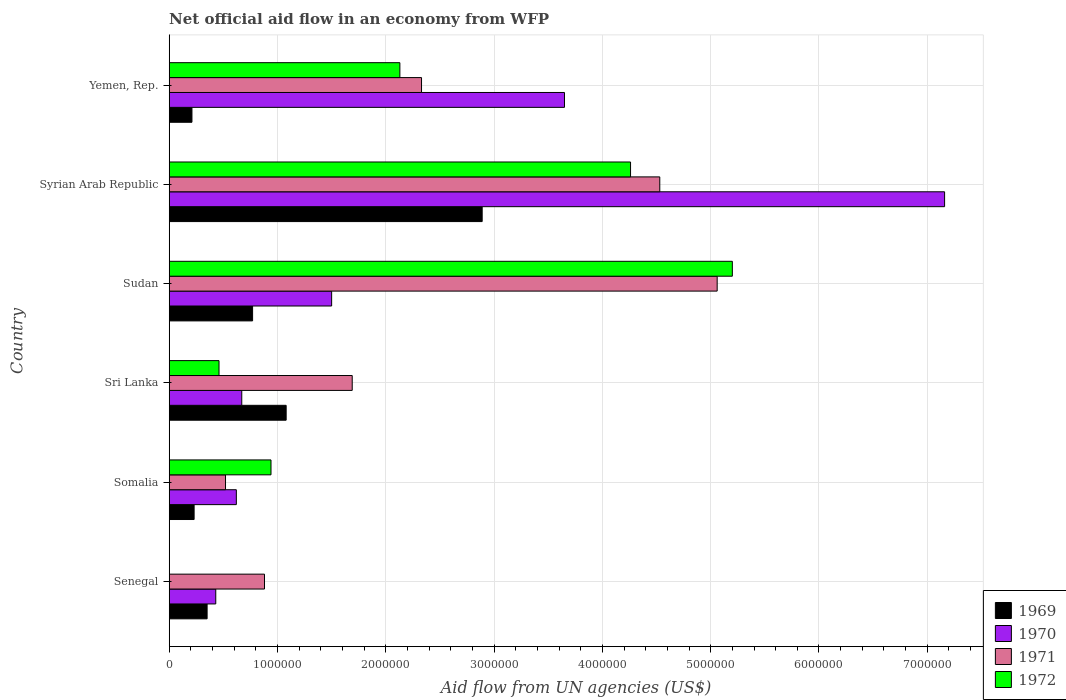How many groups of bars are there?
Offer a very short reply. 6. Are the number of bars on each tick of the Y-axis equal?
Provide a short and direct response. No. How many bars are there on the 4th tick from the top?
Make the answer very short. 4. What is the label of the 6th group of bars from the top?
Give a very brief answer. Senegal. What is the net official aid flow in 1970 in Sri Lanka?
Your answer should be very brief. 6.70e+05. Across all countries, what is the maximum net official aid flow in 1971?
Ensure brevity in your answer.  5.06e+06. In which country was the net official aid flow in 1971 maximum?
Give a very brief answer. Sudan. What is the total net official aid flow in 1971 in the graph?
Ensure brevity in your answer.  1.50e+07. What is the difference between the net official aid flow in 1972 in Somalia and the net official aid flow in 1969 in Senegal?
Give a very brief answer. 5.90e+05. What is the average net official aid flow in 1970 per country?
Your response must be concise. 2.34e+06. What is the difference between the net official aid flow in 1972 and net official aid flow in 1971 in Sudan?
Give a very brief answer. 1.40e+05. In how many countries, is the net official aid flow in 1969 greater than 4200000 US$?
Your answer should be very brief. 0. What is the ratio of the net official aid flow in 1970 in Somalia to that in Sudan?
Your answer should be compact. 0.41. What is the difference between the highest and the second highest net official aid flow in 1971?
Offer a terse response. 5.30e+05. What is the difference between the highest and the lowest net official aid flow in 1972?
Offer a terse response. 5.20e+06. Is it the case that in every country, the sum of the net official aid flow in 1969 and net official aid flow in 1970 is greater than the net official aid flow in 1971?
Make the answer very short. No. What is the difference between two consecutive major ticks on the X-axis?
Provide a succinct answer. 1.00e+06. Does the graph contain grids?
Offer a terse response. Yes. Where does the legend appear in the graph?
Give a very brief answer. Bottom right. How many legend labels are there?
Offer a very short reply. 4. What is the title of the graph?
Provide a succinct answer. Net official aid flow in an economy from WFP. What is the label or title of the X-axis?
Your answer should be compact. Aid flow from UN agencies (US$). What is the label or title of the Y-axis?
Your response must be concise. Country. What is the Aid flow from UN agencies (US$) of 1969 in Senegal?
Your response must be concise. 3.50e+05. What is the Aid flow from UN agencies (US$) of 1970 in Senegal?
Offer a terse response. 4.30e+05. What is the Aid flow from UN agencies (US$) in 1971 in Senegal?
Provide a succinct answer. 8.80e+05. What is the Aid flow from UN agencies (US$) in 1970 in Somalia?
Your response must be concise. 6.20e+05. What is the Aid flow from UN agencies (US$) in 1971 in Somalia?
Your response must be concise. 5.20e+05. What is the Aid flow from UN agencies (US$) of 1972 in Somalia?
Provide a short and direct response. 9.40e+05. What is the Aid flow from UN agencies (US$) of 1969 in Sri Lanka?
Keep it short and to the point. 1.08e+06. What is the Aid flow from UN agencies (US$) of 1970 in Sri Lanka?
Provide a short and direct response. 6.70e+05. What is the Aid flow from UN agencies (US$) in 1971 in Sri Lanka?
Make the answer very short. 1.69e+06. What is the Aid flow from UN agencies (US$) of 1969 in Sudan?
Offer a terse response. 7.70e+05. What is the Aid flow from UN agencies (US$) of 1970 in Sudan?
Keep it short and to the point. 1.50e+06. What is the Aid flow from UN agencies (US$) in 1971 in Sudan?
Ensure brevity in your answer.  5.06e+06. What is the Aid flow from UN agencies (US$) in 1972 in Sudan?
Give a very brief answer. 5.20e+06. What is the Aid flow from UN agencies (US$) of 1969 in Syrian Arab Republic?
Provide a succinct answer. 2.89e+06. What is the Aid flow from UN agencies (US$) of 1970 in Syrian Arab Republic?
Give a very brief answer. 7.16e+06. What is the Aid flow from UN agencies (US$) in 1971 in Syrian Arab Republic?
Your response must be concise. 4.53e+06. What is the Aid flow from UN agencies (US$) in 1972 in Syrian Arab Republic?
Your answer should be compact. 4.26e+06. What is the Aid flow from UN agencies (US$) of 1969 in Yemen, Rep.?
Offer a very short reply. 2.10e+05. What is the Aid flow from UN agencies (US$) in 1970 in Yemen, Rep.?
Give a very brief answer. 3.65e+06. What is the Aid flow from UN agencies (US$) in 1971 in Yemen, Rep.?
Offer a terse response. 2.33e+06. What is the Aid flow from UN agencies (US$) of 1972 in Yemen, Rep.?
Offer a very short reply. 2.13e+06. Across all countries, what is the maximum Aid flow from UN agencies (US$) in 1969?
Provide a succinct answer. 2.89e+06. Across all countries, what is the maximum Aid flow from UN agencies (US$) in 1970?
Your answer should be very brief. 7.16e+06. Across all countries, what is the maximum Aid flow from UN agencies (US$) in 1971?
Make the answer very short. 5.06e+06. Across all countries, what is the maximum Aid flow from UN agencies (US$) of 1972?
Your answer should be compact. 5.20e+06. Across all countries, what is the minimum Aid flow from UN agencies (US$) in 1969?
Offer a terse response. 2.10e+05. Across all countries, what is the minimum Aid flow from UN agencies (US$) in 1970?
Provide a succinct answer. 4.30e+05. Across all countries, what is the minimum Aid flow from UN agencies (US$) of 1971?
Your answer should be very brief. 5.20e+05. Across all countries, what is the minimum Aid flow from UN agencies (US$) of 1972?
Offer a terse response. 0. What is the total Aid flow from UN agencies (US$) in 1969 in the graph?
Your answer should be compact. 5.53e+06. What is the total Aid flow from UN agencies (US$) of 1970 in the graph?
Your response must be concise. 1.40e+07. What is the total Aid flow from UN agencies (US$) of 1971 in the graph?
Your answer should be compact. 1.50e+07. What is the total Aid flow from UN agencies (US$) of 1972 in the graph?
Provide a succinct answer. 1.30e+07. What is the difference between the Aid flow from UN agencies (US$) of 1969 in Senegal and that in Somalia?
Keep it short and to the point. 1.20e+05. What is the difference between the Aid flow from UN agencies (US$) of 1969 in Senegal and that in Sri Lanka?
Offer a terse response. -7.30e+05. What is the difference between the Aid flow from UN agencies (US$) of 1970 in Senegal and that in Sri Lanka?
Ensure brevity in your answer.  -2.40e+05. What is the difference between the Aid flow from UN agencies (US$) of 1971 in Senegal and that in Sri Lanka?
Keep it short and to the point. -8.10e+05. What is the difference between the Aid flow from UN agencies (US$) of 1969 in Senegal and that in Sudan?
Provide a short and direct response. -4.20e+05. What is the difference between the Aid flow from UN agencies (US$) of 1970 in Senegal and that in Sudan?
Your response must be concise. -1.07e+06. What is the difference between the Aid flow from UN agencies (US$) of 1971 in Senegal and that in Sudan?
Offer a very short reply. -4.18e+06. What is the difference between the Aid flow from UN agencies (US$) of 1969 in Senegal and that in Syrian Arab Republic?
Offer a terse response. -2.54e+06. What is the difference between the Aid flow from UN agencies (US$) in 1970 in Senegal and that in Syrian Arab Republic?
Give a very brief answer. -6.73e+06. What is the difference between the Aid flow from UN agencies (US$) of 1971 in Senegal and that in Syrian Arab Republic?
Your response must be concise. -3.65e+06. What is the difference between the Aid flow from UN agencies (US$) of 1970 in Senegal and that in Yemen, Rep.?
Your answer should be very brief. -3.22e+06. What is the difference between the Aid flow from UN agencies (US$) of 1971 in Senegal and that in Yemen, Rep.?
Provide a short and direct response. -1.45e+06. What is the difference between the Aid flow from UN agencies (US$) in 1969 in Somalia and that in Sri Lanka?
Keep it short and to the point. -8.50e+05. What is the difference between the Aid flow from UN agencies (US$) of 1971 in Somalia and that in Sri Lanka?
Provide a succinct answer. -1.17e+06. What is the difference between the Aid flow from UN agencies (US$) of 1969 in Somalia and that in Sudan?
Offer a very short reply. -5.40e+05. What is the difference between the Aid flow from UN agencies (US$) in 1970 in Somalia and that in Sudan?
Make the answer very short. -8.80e+05. What is the difference between the Aid flow from UN agencies (US$) in 1971 in Somalia and that in Sudan?
Offer a very short reply. -4.54e+06. What is the difference between the Aid flow from UN agencies (US$) of 1972 in Somalia and that in Sudan?
Provide a succinct answer. -4.26e+06. What is the difference between the Aid flow from UN agencies (US$) in 1969 in Somalia and that in Syrian Arab Republic?
Your response must be concise. -2.66e+06. What is the difference between the Aid flow from UN agencies (US$) in 1970 in Somalia and that in Syrian Arab Republic?
Your answer should be very brief. -6.54e+06. What is the difference between the Aid flow from UN agencies (US$) in 1971 in Somalia and that in Syrian Arab Republic?
Keep it short and to the point. -4.01e+06. What is the difference between the Aid flow from UN agencies (US$) of 1972 in Somalia and that in Syrian Arab Republic?
Ensure brevity in your answer.  -3.32e+06. What is the difference between the Aid flow from UN agencies (US$) in 1969 in Somalia and that in Yemen, Rep.?
Keep it short and to the point. 2.00e+04. What is the difference between the Aid flow from UN agencies (US$) in 1970 in Somalia and that in Yemen, Rep.?
Keep it short and to the point. -3.03e+06. What is the difference between the Aid flow from UN agencies (US$) in 1971 in Somalia and that in Yemen, Rep.?
Offer a terse response. -1.81e+06. What is the difference between the Aid flow from UN agencies (US$) of 1972 in Somalia and that in Yemen, Rep.?
Provide a succinct answer. -1.19e+06. What is the difference between the Aid flow from UN agencies (US$) of 1969 in Sri Lanka and that in Sudan?
Give a very brief answer. 3.10e+05. What is the difference between the Aid flow from UN agencies (US$) of 1970 in Sri Lanka and that in Sudan?
Give a very brief answer. -8.30e+05. What is the difference between the Aid flow from UN agencies (US$) in 1971 in Sri Lanka and that in Sudan?
Provide a short and direct response. -3.37e+06. What is the difference between the Aid flow from UN agencies (US$) in 1972 in Sri Lanka and that in Sudan?
Make the answer very short. -4.74e+06. What is the difference between the Aid flow from UN agencies (US$) in 1969 in Sri Lanka and that in Syrian Arab Republic?
Make the answer very short. -1.81e+06. What is the difference between the Aid flow from UN agencies (US$) of 1970 in Sri Lanka and that in Syrian Arab Republic?
Keep it short and to the point. -6.49e+06. What is the difference between the Aid flow from UN agencies (US$) in 1971 in Sri Lanka and that in Syrian Arab Republic?
Ensure brevity in your answer.  -2.84e+06. What is the difference between the Aid flow from UN agencies (US$) in 1972 in Sri Lanka and that in Syrian Arab Republic?
Keep it short and to the point. -3.80e+06. What is the difference between the Aid flow from UN agencies (US$) of 1969 in Sri Lanka and that in Yemen, Rep.?
Provide a succinct answer. 8.70e+05. What is the difference between the Aid flow from UN agencies (US$) in 1970 in Sri Lanka and that in Yemen, Rep.?
Your answer should be compact. -2.98e+06. What is the difference between the Aid flow from UN agencies (US$) of 1971 in Sri Lanka and that in Yemen, Rep.?
Ensure brevity in your answer.  -6.40e+05. What is the difference between the Aid flow from UN agencies (US$) of 1972 in Sri Lanka and that in Yemen, Rep.?
Ensure brevity in your answer.  -1.67e+06. What is the difference between the Aid flow from UN agencies (US$) of 1969 in Sudan and that in Syrian Arab Republic?
Keep it short and to the point. -2.12e+06. What is the difference between the Aid flow from UN agencies (US$) of 1970 in Sudan and that in Syrian Arab Republic?
Your answer should be compact. -5.66e+06. What is the difference between the Aid flow from UN agencies (US$) in 1971 in Sudan and that in Syrian Arab Republic?
Ensure brevity in your answer.  5.30e+05. What is the difference between the Aid flow from UN agencies (US$) in 1972 in Sudan and that in Syrian Arab Republic?
Your answer should be compact. 9.40e+05. What is the difference between the Aid flow from UN agencies (US$) in 1969 in Sudan and that in Yemen, Rep.?
Ensure brevity in your answer.  5.60e+05. What is the difference between the Aid flow from UN agencies (US$) of 1970 in Sudan and that in Yemen, Rep.?
Give a very brief answer. -2.15e+06. What is the difference between the Aid flow from UN agencies (US$) of 1971 in Sudan and that in Yemen, Rep.?
Your response must be concise. 2.73e+06. What is the difference between the Aid flow from UN agencies (US$) of 1972 in Sudan and that in Yemen, Rep.?
Make the answer very short. 3.07e+06. What is the difference between the Aid flow from UN agencies (US$) in 1969 in Syrian Arab Republic and that in Yemen, Rep.?
Keep it short and to the point. 2.68e+06. What is the difference between the Aid flow from UN agencies (US$) of 1970 in Syrian Arab Republic and that in Yemen, Rep.?
Ensure brevity in your answer.  3.51e+06. What is the difference between the Aid flow from UN agencies (US$) in 1971 in Syrian Arab Republic and that in Yemen, Rep.?
Keep it short and to the point. 2.20e+06. What is the difference between the Aid flow from UN agencies (US$) of 1972 in Syrian Arab Republic and that in Yemen, Rep.?
Offer a terse response. 2.13e+06. What is the difference between the Aid flow from UN agencies (US$) of 1969 in Senegal and the Aid flow from UN agencies (US$) of 1970 in Somalia?
Offer a very short reply. -2.70e+05. What is the difference between the Aid flow from UN agencies (US$) of 1969 in Senegal and the Aid flow from UN agencies (US$) of 1971 in Somalia?
Provide a short and direct response. -1.70e+05. What is the difference between the Aid flow from UN agencies (US$) of 1969 in Senegal and the Aid flow from UN agencies (US$) of 1972 in Somalia?
Make the answer very short. -5.90e+05. What is the difference between the Aid flow from UN agencies (US$) in 1970 in Senegal and the Aid flow from UN agencies (US$) in 1971 in Somalia?
Offer a very short reply. -9.00e+04. What is the difference between the Aid flow from UN agencies (US$) in 1970 in Senegal and the Aid flow from UN agencies (US$) in 1972 in Somalia?
Ensure brevity in your answer.  -5.10e+05. What is the difference between the Aid flow from UN agencies (US$) in 1971 in Senegal and the Aid flow from UN agencies (US$) in 1972 in Somalia?
Your response must be concise. -6.00e+04. What is the difference between the Aid flow from UN agencies (US$) in 1969 in Senegal and the Aid flow from UN agencies (US$) in 1970 in Sri Lanka?
Ensure brevity in your answer.  -3.20e+05. What is the difference between the Aid flow from UN agencies (US$) of 1969 in Senegal and the Aid flow from UN agencies (US$) of 1971 in Sri Lanka?
Offer a very short reply. -1.34e+06. What is the difference between the Aid flow from UN agencies (US$) in 1969 in Senegal and the Aid flow from UN agencies (US$) in 1972 in Sri Lanka?
Ensure brevity in your answer.  -1.10e+05. What is the difference between the Aid flow from UN agencies (US$) of 1970 in Senegal and the Aid flow from UN agencies (US$) of 1971 in Sri Lanka?
Your response must be concise. -1.26e+06. What is the difference between the Aid flow from UN agencies (US$) in 1970 in Senegal and the Aid flow from UN agencies (US$) in 1972 in Sri Lanka?
Provide a short and direct response. -3.00e+04. What is the difference between the Aid flow from UN agencies (US$) in 1971 in Senegal and the Aid flow from UN agencies (US$) in 1972 in Sri Lanka?
Ensure brevity in your answer.  4.20e+05. What is the difference between the Aid flow from UN agencies (US$) of 1969 in Senegal and the Aid flow from UN agencies (US$) of 1970 in Sudan?
Your answer should be very brief. -1.15e+06. What is the difference between the Aid flow from UN agencies (US$) in 1969 in Senegal and the Aid flow from UN agencies (US$) in 1971 in Sudan?
Provide a succinct answer. -4.71e+06. What is the difference between the Aid flow from UN agencies (US$) of 1969 in Senegal and the Aid flow from UN agencies (US$) of 1972 in Sudan?
Give a very brief answer. -4.85e+06. What is the difference between the Aid flow from UN agencies (US$) of 1970 in Senegal and the Aid flow from UN agencies (US$) of 1971 in Sudan?
Ensure brevity in your answer.  -4.63e+06. What is the difference between the Aid flow from UN agencies (US$) in 1970 in Senegal and the Aid flow from UN agencies (US$) in 1972 in Sudan?
Offer a very short reply. -4.77e+06. What is the difference between the Aid flow from UN agencies (US$) of 1971 in Senegal and the Aid flow from UN agencies (US$) of 1972 in Sudan?
Keep it short and to the point. -4.32e+06. What is the difference between the Aid flow from UN agencies (US$) of 1969 in Senegal and the Aid flow from UN agencies (US$) of 1970 in Syrian Arab Republic?
Provide a succinct answer. -6.81e+06. What is the difference between the Aid flow from UN agencies (US$) of 1969 in Senegal and the Aid flow from UN agencies (US$) of 1971 in Syrian Arab Republic?
Make the answer very short. -4.18e+06. What is the difference between the Aid flow from UN agencies (US$) of 1969 in Senegal and the Aid flow from UN agencies (US$) of 1972 in Syrian Arab Republic?
Give a very brief answer. -3.91e+06. What is the difference between the Aid flow from UN agencies (US$) of 1970 in Senegal and the Aid flow from UN agencies (US$) of 1971 in Syrian Arab Republic?
Offer a terse response. -4.10e+06. What is the difference between the Aid flow from UN agencies (US$) in 1970 in Senegal and the Aid flow from UN agencies (US$) in 1972 in Syrian Arab Republic?
Provide a succinct answer. -3.83e+06. What is the difference between the Aid flow from UN agencies (US$) in 1971 in Senegal and the Aid flow from UN agencies (US$) in 1972 in Syrian Arab Republic?
Offer a terse response. -3.38e+06. What is the difference between the Aid flow from UN agencies (US$) in 1969 in Senegal and the Aid flow from UN agencies (US$) in 1970 in Yemen, Rep.?
Provide a succinct answer. -3.30e+06. What is the difference between the Aid flow from UN agencies (US$) in 1969 in Senegal and the Aid flow from UN agencies (US$) in 1971 in Yemen, Rep.?
Ensure brevity in your answer.  -1.98e+06. What is the difference between the Aid flow from UN agencies (US$) of 1969 in Senegal and the Aid flow from UN agencies (US$) of 1972 in Yemen, Rep.?
Offer a terse response. -1.78e+06. What is the difference between the Aid flow from UN agencies (US$) in 1970 in Senegal and the Aid flow from UN agencies (US$) in 1971 in Yemen, Rep.?
Ensure brevity in your answer.  -1.90e+06. What is the difference between the Aid flow from UN agencies (US$) in 1970 in Senegal and the Aid flow from UN agencies (US$) in 1972 in Yemen, Rep.?
Offer a terse response. -1.70e+06. What is the difference between the Aid flow from UN agencies (US$) of 1971 in Senegal and the Aid flow from UN agencies (US$) of 1972 in Yemen, Rep.?
Your answer should be compact. -1.25e+06. What is the difference between the Aid flow from UN agencies (US$) of 1969 in Somalia and the Aid flow from UN agencies (US$) of 1970 in Sri Lanka?
Offer a very short reply. -4.40e+05. What is the difference between the Aid flow from UN agencies (US$) in 1969 in Somalia and the Aid flow from UN agencies (US$) in 1971 in Sri Lanka?
Offer a very short reply. -1.46e+06. What is the difference between the Aid flow from UN agencies (US$) of 1969 in Somalia and the Aid flow from UN agencies (US$) of 1972 in Sri Lanka?
Make the answer very short. -2.30e+05. What is the difference between the Aid flow from UN agencies (US$) of 1970 in Somalia and the Aid flow from UN agencies (US$) of 1971 in Sri Lanka?
Give a very brief answer. -1.07e+06. What is the difference between the Aid flow from UN agencies (US$) of 1970 in Somalia and the Aid flow from UN agencies (US$) of 1972 in Sri Lanka?
Give a very brief answer. 1.60e+05. What is the difference between the Aid flow from UN agencies (US$) of 1971 in Somalia and the Aid flow from UN agencies (US$) of 1972 in Sri Lanka?
Your response must be concise. 6.00e+04. What is the difference between the Aid flow from UN agencies (US$) in 1969 in Somalia and the Aid flow from UN agencies (US$) in 1970 in Sudan?
Your answer should be very brief. -1.27e+06. What is the difference between the Aid flow from UN agencies (US$) in 1969 in Somalia and the Aid flow from UN agencies (US$) in 1971 in Sudan?
Provide a succinct answer. -4.83e+06. What is the difference between the Aid flow from UN agencies (US$) in 1969 in Somalia and the Aid flow from UN agencies (US$) in 1972 in Sudan?
Ensure brevity in your answer.  -4.97e+06. What is the difference between the Aid flow from UN agencies (US$) in 1970 in Somalia and the Aid flow from UN agencies (US$) in 1971 in Sudan?
Keep it short and to the point. -4.44e+06. What is the difference between the Aid flow from UN agencies (US$) of 1970 in Somalia and the Aid flow from UN agencies (US$) of 1972 in Sudan?
Give a very brief answer. -4.58e+06. What is the difference between the Aid flow from UN agencies (US$) in 1971 in Somalia and the Aid flow from UN agencies (US$) in 1972 in Sudan?
Your answer should be compact. -4.68e+06. What is the difference between the Aid flow from UN agencies (US$) in 1969 in Somalia and the Aid flow from UN agencies (US$) in 1970 in Syrian Arab Republic?
Ensure brevity in your answer.  -6.93e+06. What is the difference between the Aid flow from UN agencies (US$) of 1969 in Somalia and the Aid flow from UN agencies (US$) of 1971 in Syrian Arab Republic?
Ensure brevity in your answer.  -4.30e+06. What is the difference between the Aid flow from UN agencies (US$) of 1969 in Somalia and the Aid flow from UN agencies (US$) of 1972 in Syrian Arab Republic?
Ensure brevity in your answer.  -4.03e+06. What is the difference between the Aid flow from UN agencies (US$) in 1970 in Somalia and the Aid flow from UN agencies (US$) in 1971 in Syrian Arab Republic?
Give a very brief answer. -3.91e+06. What is the difference between the Aid flow from UN agencies (US$) in 1970 in Somalia and the Aid flow from UN agencies (US$) in 1972 in Syrian Arab Republic?
Provide a succinct answer. -3.64e+06. What is the difference between the Aid flow from UN agencies (US$) of 1971 in Somalia and the Aid flow from UN agencies (US$) of 1972 in Syrian Arab Republic?
Keep it short and to the point. -3.74e+06. What is the difference between the Aid flow from UN agencies (US$) of 1969 in Somalia and the Aid flow from UN agencies (US$) of 1970 in Yemen, Rep.?
Provide a succinct answer. -3.42e+06. What is the difference between the Aid flow from UN agencies (US$) of 1969 in Somalia and the Aid flow from UN agencies (US$) of 1971 in Yemen, Rep.?
Your answer should be compact. -2.10e+06. What is the difference between the Aid flow from UN agencies (US$) in 1969 in Somalia and the Aid flow from UN agencies (US$) in 1972 in Yemen, Rep.?
Your response must be concise. -1.90e+06. What is the difference between the Aid flow from UN agencies (US$) in 1970 in Somalia and the Aid flow from UN agencies (US$) in 1971 in Yemen, Rep.?
Your answer should be compact. -1.71e+06. What is the difference between the Aid flow from UN agencies (US$) of 1970 in Somalia and the Aid flow from UN agencies (US$) of 1972 in Yemen, Rep.?
Offer a terse response. -1.51e+06. What is the difference between the Aid flow from UN agencies (US$) in 1971 in Somalia and the Aid flow from UN agencies (US$) in 1972 in Yemen, Rep.?
Provide a short and direct response. -1.61e+06. What is the difference between the Aid flow from UN agencies (US$) in 1969 in Sri Lanka and the Aid flow from UN agencies (US$) in 1970 in Sudan?
Your response must be concise. -4.20e+05. What is the difference between the Aid flow from UN agencies (US$) of 1969 in Sri Lanka and the Aid flow from UN agencies (US$) of 1971 in Sudan?
Provide a short and direct response. -3.98e+06. What is the difference between the Aid flow from UN agencies (US$) in 1969 in Sri Lanka and the Aid flow from UN agencies (US$) in 1972 in Sudan?
Provide a short and direct response. -4.12e+06. What is the difference between the Aid flow from UN agencies (US$) of 1970 in Sri Lanka and the Aid flow from UN agencies (US$) of 1971 in Sudan?
Your answer should be very brief. -4.39e+06. What is the difference between the Aid flow from UN agencies (US$) in 1970 in Sri Lanka and the Aid flow from UN agencies (US$) in 1972 in Sudan?
Give a very brief answer. -4.53e+06. What is the difference between the Aid flow from UN agencies (US$) of 1971 in Sri Lanka and the Aid flow from UN agencies (US$) of 1972 in Sudan?
Your answer should be very brief. -3.51e+06. What is the difference between the Aid flow from UN agencies (US$) in 1969 in Sri Lanka and the Aid flow from UN agencies (US$) in 1970 in Syrian Arab Republic?
Ensure brevity in your answer.  -6.08e+06. What is the difference between the Aid flow from UN agencies (US$) in 1969 in Sri Lanka and the Aid flow from UN agencies (US$) in 1971 in Syrian Arab Republic?
Your answer should be compact. -3.45e+06. What is the difference between the Aid flow from UN agencies (US$) in 1969 in Sri Lanka and the Aid flow from UN agencies (US$) in 1972 in Syrian Arab Republic?
Keep it short and to the point. -3.18e+06. What is the difference between the Aid flow from UN agencies (US$) of 1970 in Sri Lanka and the Aid flow from UN agencies (US$) of 1971 in Syrian Arab Republic?
Offer a terse response. -3.86e+06. What is the difference between the Aid flow from UN agencies (US$) in 1970 in Sri Lanka and the Aid flow from UN agencies (US$) in 1972 in Syrian Arab Republic?
Give a very brief answer. -3.59e+06. What is the difference between the Aid flow from UN agencies (US$) in 1971 in Sri Lanka and the Aid flow from UN agencies (US$) in 1972 in Syrian Arab Republic?
Make the answer very short. -2.57e+06. What is the difference between the Aid flow from UN agencies (US$) in 1969 in Sri Lanka and the Aid flow from UN agencies (US$) in 1970 in Yemen, Rep.?
Give a very brief answer. -2.57e+06. What is the difference between the Aid flow from UN agencies (US$) in 1969 in Sri Lanka and the Aid flow from UN agencies (US$) in 1971 in Yemen, Rep.?
Ensure brevity in your answer.  -1.25e+06. What is the difference between the Aid flow from UN agencies (US$) in 1969 in Sri Lanka and the Aid flow from UN agencies (US$) in 1972 in Yemen, Rep.?
Offer a terse response. -1.05e+06. What is the difference between the Aid flow from UN agencies (US$) of 1970 in Sri Lanka and the Aid flow from UN agencies (US$) of 1971 in Yemen, Rep.?
Your answer should be compact. -1.66e+06. What is the difference between the Aid flow from UN agencies (US$) in 1970 in Sri Lanka and the Aid flow from UN agencies (US$) in 1972 in Yemen, Rep.?
Ensure brevity in your answer.  -1.46e+06. What is the difference between the Aid flow from UN agencies (US$) in 1971 in Sri Lanka and the Aid flow from UN agencies (US$) in 1972 in Yemen, Rep.?
Provide a succinct answer. -4.40e+05. What is the difference between the Aid flow from UN agencies (US$) in 1969 in Sudan and the Aid flow from UN agencies (US$) in 1970 in Syrian Arab Republic?
Your response must be concise. -6.39e+06. What is the difference between the Aid flow from UN agencies (US$) of 1969 in Sudan and the Aid flow from UN agencies (US$) of 1971 in Syrian Arab Republic?
Give a very brief answer. -3.76e+06. What is the difference between the Aid flow from UN agencies (US$) in 1969 in Sudan and the Aid flow from UN agencies (US$) in 1972 in Syrian Arab Republic?
Your response must be concise. -3.49e+06. What is the difference between the Aid flow from UN agencies (US$) in 1970 in Sudan and the Aid flow from UN agencies (US$) in 1971 in Syrian Arab Republic?
Keep it short and to the point. -3.03e+06. What is the difference between the Aid flow from UN agencies (US$) in 1970 in Sudan and the Aid flow from UN agencies (US$) in 1972 in Syrian Arab Republic?
Ensure brevity in your answer.  -2.76e+06. What is the difference between the Aid flow from UN agencies (US$) in 1971 in Sudan and the Aid flow from UN agencies (US$) in 1972 in Syrian Arab Republic?
Offer a terse response. 8.00e+05. What is the difference between the Aid flow from UN agencies (US$) of 1969 in Sudan and the Aid flow from UN agencies (US$) of 1970 in Yemen, Rep.?
Provide a succinct answer. -2.88e+06. What is the difference between the Aid flow from UN agencies (US$) in 1969 in Sudan and the Aid flow from UN agencies (US$) in 1971 in Yemen, Rep.?
Keep it short and to the point. -1.56e+06. What is the difference between the Aid flow from UN agencies (US$) in 1969 in Sudan and the Aid flow from UN agencies (US$) in 1972 in Yemen, Rep.?
Keep it short and to the point. -1.36e+06. What is the difference between the Aid flow from UN agencies (US$) in 1970 in Sudan and the Aid flow from UN agencies (US$) in 1971 in Yemen, Rep.?
Provide a short and direct response. -8.30e+05. What is the difference between the Aid flow from UN agencies (US$) of 1970 in Sudan and the Aid flow from UN agencies (US$) of 1972 in Yemen, Rep.?
Your response must be concise. -6.30e+05. What is the difference between the Aid flow from UN agencies (US$) in 1971 in Sudan and the Aid flow from UN agencies (US$) in 1972 in Yemen, Rep.?
Your response must be concise. 2.93e+06. What is the difference between the Aid flow from UN agencies (US$) of 1969 in Syrian Arab Republic and the Aid flow from UN agencies (US$) of 1970 in Yemen, Rep.?
Make the answer very short. -7.60e+05. What is the difference between the Aid flow from UN agencies (US$) in 1969 in Syrian Arab Republic and the Aid flow from UN agencies (US$) in 1971 in Yemen, Rep.?
Your response must be concise. 5.60e+05. What is the difference between the Aid flow from UN agencies (US$) of 1969 in Syrian Arab Republic and the Aid flow from UN agencies (US$) of 1972 in Yemen, Rep.?
Your answer should be very brief. 7.60e+05. What is the difference between the Aid flow from UN agencies (US$) in 1970 in Syrian Arab Republic and the Aid flow from UN agencies (US$) in 1971 in Yemen, Rep.?
Your response must be concise. 4.83e+06. What is the difference between the Aid flow from UN agencies (US$) in 1970 in Syrian Arab Republic and the Aid flow from UN agencies (US$) in 1972 in Yemen, Rep.?
Your answer should be very brief. 5.03e+06. What is the difference between the Aid flow from UN agencies (US$) of 1971 in Syrian Arab Republic and the Aid flow from UN agencies (US$) of 1972 in Yemen, Rep.?
Make the answer very short. 2.40e+06. What is the average Aid flow from UN agencies (US$) in 1969 per country?
Provide a succinct answer. 9.22e+05. What is the average Aid flow from UN agencies (US$) in 1970 per country?
Offer a terse response. 2.34e+06. What is the average Aid flow from UN agencies (US$) in 1971 per country?
Offer a terse response. 2.50e+06. What is the average Aid flow from UN agencies (US$) in 1972 per country?
Ensure brevity in your answer.  2.16e+06. What is the difference between the Aid flow from UN agencies (US$) in 1969 and Aid flow from UN agencies (US$) in 1970 in Senegal?
Your answer should be compact. -8.00e+04. What is the difference between the Aid flow from UN agencies (US$) in 1969 and Aid flow from UN agencies (US$) in 1971 in Senegal?
Offer a very short reply. -5.30e+05. What is the difference between the Aid flow from UN agencies (US$) in 1970 and Aid flow from UN agencies (US$) in 1971 in Senegal?
Your answer should be very brief. -4.50e+05. What is the difference between the Aid flow from UN agencies (US$) of 1969 and Aid flow from UN agencies (US$) of 1970 in Somalia?
Give a very brief answer. -3.90e+05. What is the difference between the Aid flow from UN agencies (US$) of 1969 and Aid flow from UN agencies (US$) of 1972 in Somalia?
Give a very brief answer. -7.10e+05. What is the difference between the Aid flow from UN agencies (US$) of 1970 and Aid flow from UN agencies (US$) of 1972 in Somalia?
Offer a very short reply. -3.20e+05. What is the difference between the Aid flow from UN agencies (US$) of 1971 and Aid flow from UN agencies (US$) of 1972 in Somalia?
Keep it short and to the point. -4.20e+05. What is the difference between the Aid flow from UN agencies (US$) of 1969 and Aid flow from UN agencies (US$) of 1971 in Sri Lanka?
Offer a terse response. -6.10e+05. What is the difference between the Aid flow from UN agencies (US$) of 1969 and Aid flow from UN agencies (US$) of 1972 in Sri Lanka?
Make the answer very short. 6.20e+05. What is the difference between the Aid flow from UN agencies (US$) of 1970 and Aid flow from UN agencies (US$) of 1971 in Sri Lanka?
Provide a short and direct response. -1.02e+06. What is the difference between the Aid flow from UN agencies (US$) of 1970 and Aid flow from UN agencies (US$) of 1972 in Sri Lanka?
Provide a succinct answer. 2.10e+05. What is the difference between the Aid flow from UN agencies (US$) in 1971 and Aid flow from UN agencies (US$) in 1972 in Sri Lanka?
Your answer should be compact. 1.23e+06. What is the difference between the Aid flow from UN agencies (US$) of 1969 and Aid flow from UN agencies (US$) of 1970 in Sudan?
Keep it short and to the point. -7.30e+05. What is the difference between the Aid flow from UN agencies (US$) of 1969 and Aid flow from UN agencies (US$) of 1971 in Sudan?
Your response must be concise. -4.29e+06. What is the difference between the Aid flow from UN agencies (US$) in 1969 and Aid flow from UN agencies (US$) in 1972 in Sudan?
Offer a terse response. -4.43e+06. What is the difference between the Aid flow from UN agencies (US$) of 1970 and Aid flow from UN agencies (US$) of 1971 in Sudan?
Provide a succinct answer. -3.56e+06. What is the difference between the Aid flow from UN agencies (US$) of 1970 and Aid flow from UN agencies (US$) of 1972 in Sudan?
Your answer should be compact. -3.70e+06. What is the difference between the Aid flow from UN agencies (US$) of 1969 and Aid flow from UN agencies (US$) of 1970 in Syrian Arab Republic?
Give a very brief answer. -4.27e+06. What is the difference between the Aid flow from UN agencies (US$) of 1969 and Aid flow from UN agencies (US$) of 1971 in Syrian Arab Republic?
Provide a short and direct response. -1.64e+06. What is the difference between the Aid flow from UN agencies (US$) in 1969 and Aid flow from UN agencies (US$) in 1972 in Syrian Arab Republic?
Make the answer very short. -1.37e+06. What is the difference between the Aid flow from UN agencies (US$) in 1970 and Aid flow from UN agencies (US$) in 1971 in Syrian Arab Republic?
Your answer should be very brief. 2.63e+06. What is the difference between the Aid flow from UN agencies (US$) of 1970 and Aid flow from UN agencies (US$) of 1972 in Syrian Arab Republic?
Keep it short and to the point. 2.90e+06. What is the difference between the Aid flow from UN agencies (US$) in 1969 and Aid flow from UN agencies (US$) in 1970 in Yemen, Rep.?
Give a very brief answer. -3.44e+06. What is the difference between the Aid flow from UN agencies (US$) in 1969 and Aid flow from UN agencies (US$) in 1971 in Yemen, Rep.?
Provide a short and direct response. -2.12e+06. What is the difference between the Aid flow from UN agencies (US$) in 1969 and Aid flow from UN agencies (US$) in 1972 in Yemen, Rep.?
Offer a terse response. -1.92e+06. What is the difference between the Aid flow from UN agencies (US$) of 1970 and Aid flow from UN agencies (US$) of 1971 in Yemen, Rep.?
Offer a very short reply. 1.32e+06. What is the difference between the Aid flow from UN agencies (US$) of 1970 and Aid flow from UN agencies (US$) of 1972 in Yemen, Rep.?
Offer a very short reply. 1.52e+06. What is the difference between the Aid flow from UN agencies (US$) of 1971 and Aid flow from UN agencies (US$) of 1972 in Yemen, Rep.?
Offer a terse response. 2.00e+05. What is the ratio of the Aid flow from UN agencies (US$) of 1969 in Senegal to that in Somalia?
Make the answer very short. 1.52. What is the ratio of the Aid flow from UN agencies (US$) in 1970 in Senegal to that in Somalia?
Keep it short and to the point. 0.69. What is the ratio of the Aid flow from UN agencies (US$) in 1971 in Senegal to that in Somalia?
Ensure brevity in your answer.  1.69. What is the ratio of the Aid flow from UN agencies (US$) of 1969 in Senegal to that in Sri Lanka?
Your response must be concise. 0.32. What is the ratio of the Aid flow from UN agencies (US$) of 1970 in Senegal to that in Sri Lanka?
Ensure brevity in your answer.  0.64. What is the ratio of the Aid flow from UN agencies (US$) of 1971 in Senegal to that in Sri Lanka?
Provide a short and direct response. 0.52. What is the ratio of the Aid flow from UN agencies (US$) in 1969 in Senegal to that in Sudan?
Your answer should be compact. 0.45. What is the ratio of the Aid flow from UN agencies (US$) in 1970 in Senegal to that in Sudan?
Provide a succinct answer. 0.29. What is the ratio of the Aid flow from UN agencies (US$) in 1971 in Senegal to that in Sudan?
Keep it short and to the point. 0.17. What is the ratio of the Aid flow from UN agencies (US$) in 1969 in Senegal to that in Syrian Arab Republic?
Keep it short and to the point. 0.12. What is the ratio of the Aid flow from UN agencies (US$) in 1970 in Senegal to that in Syrian Arab Republic?
Give a very brief answer. 0.06. What is the ratio of the Aid flow from UN agencies (US$) in 1971 in Senegal to that in Syrian Arab Republic?
Offer a terse response. 0.19. What is the ratio of the Aid flow from UN agencies (US$) in 1970 in Senegal to that in Yemen, Rep.?
Ensure brevity in your answer.  0.12. What is the ratio of the Aid flow from UN agencies (US$) in 1971 in Senegal to that in Yemen, Rep.?
Your answer should be compact. 0.38. What is the ratio of the Aid flow from UN agencies (US$) of 1969 in Somalia to that in Sri Lanka?
Your answer should be compact. 0.21. What is the ratio of the Aid flow from UN agencies (US$) in 1970 in Somalia to that in Sri Lanka?
Your response must be concise. 0.93. What is the ratio of the Aid flow from UN agencies (US$) of 1971 in Somalia to that in Sri Lanka?
Provide a short and direct response. 0.31. What is the ratio of the Aid flow from UN agencies (US$) of 1972 in Somalia to that in Sri Lanka?
Keep it short and to the point. 2.04. What is the ratio of the Aid flow from UN agencies (US$) of 1969 in Somalia to that in Sudan?
Your answer should be very brief. 0.3. What is the ratio of the Aid flow from UN agencies (US$) in 1970 in Somalia to that in Sudan?
Your response must be concise. 0.41. What is the ratio of the Aid flow from UN agencies (US$) of 1971 in Somalia to that in Sudan?
Provide a short and direct response. 0.1. What is the ratio of the Aid flow from UN agencies (US$) of 1972 in Somalia to that in Sudan?
Keep it short and to the point. 0.18. What is the ratio of the Aid flow from UN agencies (US$) of 1969 in Somalia to that in Syrian Arab Republic?
Your answer should be very brief. 0.08. What is the ratio of the Aid flow from UN agencies (US$) in 1970 in Somalia to that in Syrian Arab Republic?
Give a very brief answer. 0.09. What is the ratio of the Aid flow from UN agencies (US$) in 1971 in Somalia to that in Syrian Arab Republic?
Provide a succinct answer. 0.11. What is the ratio of the Aid flow from UN agencies (US$) in 1972 in Somalia to that in Syrian Arab Republic?
Your answer should be compact. 0.22. What is the ratio of the Aid flow from UN agencies (US$) of 1969 in Somalia to that in Yemen, Rep.?
Provide a succinct answer. 1.1. What is the ratio of the Aid flow from UN agencies (US$) in 1970 in Somalia to that in Yemen, Rep.?
Your answer should be compact. 0.17. What is the ratio of the Aid flow from UN agencies (US$) of 1971 in Somalia to that in Yemen, Rep.?
Give a very brief answer. 0.22. What is the ratio of the Aid flow from UN agencies (US$) in 1972 in Somalia to that in Yemen, Rep.?
Keep it short and to the point. 0.44. What is the ratio of the Aid flow from UN agencies (US$) in 1969 in Sri Lanka to that in Sudan?
Offer a terse response. 1.4. What is the ratio of the Aid flow from UN agencies (US$) in 1970 in Sri Lanka to that in Sudan?
Provide a succinct answer. 0.45. What is the ratio of the Aid flow from UN agencies (US$) in 1971 in Sri Lanka to that in Sudan?
Your answer should be compact. 0.33. What is the ratio of the Aid flow from UN agencies (US$) of 1972 in Sri Lanka to that in Sudan?
Offer a terse response. 0.09. What is the ratio of the Aid flow from UN agencies (US$) of 1969 in Sri Lanka to that in Syrian Arab Republic?
Offer a very short reply. 0.37. What is the ratio of the Aid flow from UN agencies (US$) of 1970 in Sri Lanka to that in Syrian Arab Republic?
Offer a very short reply. 0.09. What is the ratio of the Aid flow from UN agencies (US$) in 1971 in Sri Lanka to that in Syrian Arab Republic?
Keep it short and to the point. 0.37. What is the ratio of the Aid flow from UN agencies (US$) of 1972 in Sri Lanka to that in Syrian Arab Republic?
Your answer should be compact. 0.11. What is the ratio of the Aid flow from UN agencies (US$) in 1969 in Sri Lanka to that in Yemen, Rep.?
Your response must be concise. 5.14. What is the ratio of the Aid flow from UN agencies (US$) in 1970 in Sri Lanka to that in Yemen, Rep.?
Your response must be concise. 0.18. What is the ratio of the Aid flow from UN agencies (US$) in 1971 in Sri Lanka to that in Yemen, Rep.?
Offer a terse response. 0.73. What is the ratio of the Aid flow from UN agencies (US$) of 1972 in Sri Lanka to that in Yemen, Rep.?
Your answer should be compact. 0.22. What is the ratio of the Aid flow from UN agencies (US$) of 1969 in Sudan to that in Syrian Arab Republic?
Keep it short and to the point. 0.27. What is the ratio of the Aid flow from UN agencies (US$) in 1970 in Sudan to that in Syrian Arab Republic?
Give a very brief answer. 0.21. What is the ratio of the Aid flow from UN agencies (US$) in 1971 in Sudan to that in Syrian Arab Republic?
Your answer should be very brief. 1.12. What is the ratio of the Aid flow from UN agencies (US$) in 1972 in Sudan to that in Syrian Arab Republic?
Make the answer very short. 1.22. What is the ratio of the Aid flow from UN agencies (US$) of 1969 in Sudan to that in Yemen, Rep.?
Provide a succinct answer. 3.67. What is the ratio of the Aid flow from UN agencies (US$) in 1970 in Sudan to that in Yemen, Rep.?
Give a very brief answer. 0.41. What is the ratio of the Aid flow from UN agencies (US$) in 1971 in Sudan to that in Yemen, Rep.?
Your answer should be very brief. 2.17. What is the ratio of the Aid flow from UN agencies (US$) in 1972 in Sudan to that in Yemen, Rep.?
Provide a short and direct response. 2.44. What is the ratio of the Aid flow from UN agencies (US$) of 1969 in Syrian Arab Republic to that in Yemen, Rep.?
Offer a terse response. 13.76. What is the ratio of the Aid flow from UN agencies (US$) of 1970 in Syrian Arab Republic to that in Yemen, Rep.?
Your answer should be compact. 1.96. What is the ratio of the Aid flow from UN agencies (US$) in 1971 in Syrian Arab Republic to that in Yemen, Rep.?
Your answer should be very brief. 1.94. What is the ratio of the Aid flow from UN agencies (US$) in 1972 in Syrian Arab Republic to that in Yemen, Rep.?
Provide a succinct answer. 2. What is the difference between the highest and the second highest Aid flow from UN agencies (US$) of 1969?
Offer a terse response. 1.81e+06. What is the difference between the highest and the second highest Aid flow from UN agencies (US$) in 1970?
Ensure brevity in your answer.  3.51e+06. What is the difference between the highest and the second highest Aid flow from UN agencies (US$) in 1971?
Your answer should be compact. 5.30e+05. What is the difference between the highest and the second highest Aid flow from UN agencies (US$) of 1972?
Offer a very short reply. 9.40e+05. What is the difference between the highest and the lowest Aid flow from UN agencies (US$) of 1969?
Your answer should be compact. 2.68e+06. What is the difference between the highest and the lowest Aid flow from UN agencies (US$) in 1970?
Offer a very short reply. 6.73e+06. What is the difference between the highest and the lowest Aid flow from UN agencies (US$) in 1971?
Ensure brevity in your answer.  4.54e+06. What is the difference between the highest and the lowest Aid flow from UN agencies (US$) in 1972?
Provide a short and direct response. 5.20e+06. 